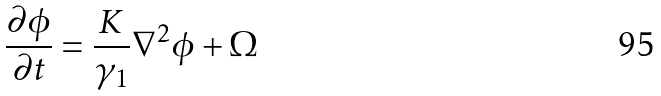<formula> <loc_0><loc_0><loc_500><loc_500>\frac { \partial \phi } { \partial t } = \frac { K } { \gamma _ { 1 } } \nabla ^ { 2 } \phi + \Omega</formula> 